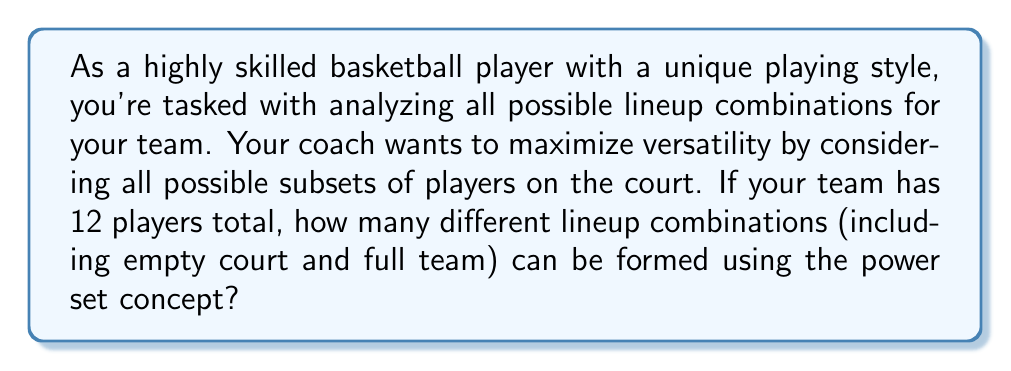Solve this math problem. To solve this problem, we need to understand and apply the concept of power sets in set theory. Let's break it down step-by-step:

1) First, recall that the power set of a set S is the set of all subsets of S, including the empty set and S itself.

2) The number of elements in the power set of a set with n elements is given by the formula:

   $$|P(S)| = 2^n$$

   Where |P(S)| denotes the cardinality (number of elements) of the power set of S.

3) In this case, we have a team of 12 players. Each player can either be in the lineup or not, which gives us two choices for each player.

4) Therefore, we can think of each subset (lineup) as a sequence of 12 binary choices (in/out). The total number of such sequences is:

   $$2 * 2 * 2 * ... * 2$$ (12 times)

   Which is equivalent to $2^{12}$

5) This includes all possible lineups:
   - The empty set (no players on the court)
   - All single-player lineups
   - All two-player lineups
   - ...
   - The full 12-player lineup

6) Calculate $2^{12}$:
   
   $$2^{12} = 4,096$$

Thus, there are 4,096 different possible lineup combinations when considering all subsets of the 12-player team.
Answer: 4,096 lineup combinations 